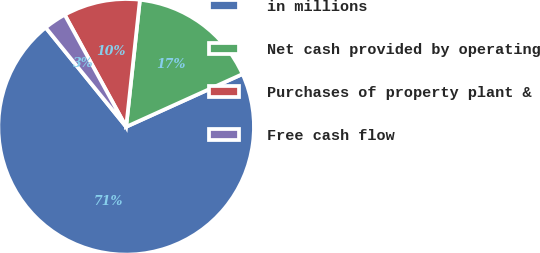Convert chart. <chart><loc_0><loc_0><loc_500><loc_500><pie_chart><fcel>in millions<fcel>Net cash provided by operating<fcel>Purchases of property plant &<fcel>Free cash flow<nl><fcel>70.93%<fcel>16.51%<fcel>9.7%<fcel>2.86%<nl></chart> 